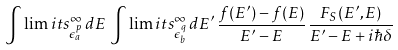Convert formula to latex. <formula><loc_0><loc_0><loc_500><loc_500>\int \lim i t s _ { \epsilon _ { a } ^ { p } } ^ { \infty } \, d E \, \int \lim i t s _ { \epsilon _ { b } ^ { q } } ^ { \infty } \, d E ^ { \prime } \, \frac { f ( E ^ { \prime } ) - f ( E ) } { E ^ { \prime } - E } \, \frac { F _ { S } ( E ^ { \prime } , E ) } { E ^ { \prime } - E + i \hbar { \delta } }</formula> 